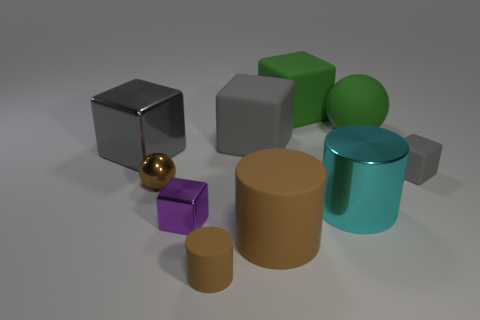Subtract all large rubber cubes. How many cubes are left? 3 Subtract all purple blocks. How many blocks are left? 4 Subtract 2 cubes. How many cubes are left? 3 Add 7 tiny brown things. How many tiny brown things are left? 9 Add 1 big matte cubes. How many big matte cubes exist? 3 Subtract 0 purple spheres. How many objects are left? 10 Subtract all cylinders. How many objects are left? 7 Subtract all purple cubes. Subtract all green spheres. How many cubes are left? 4 Subtract all cyan blocks. How many brown cylinders are left? 2 Subtract all large gray metallic cylinders. Subtract all gray cubes. How many objects are left? 7 